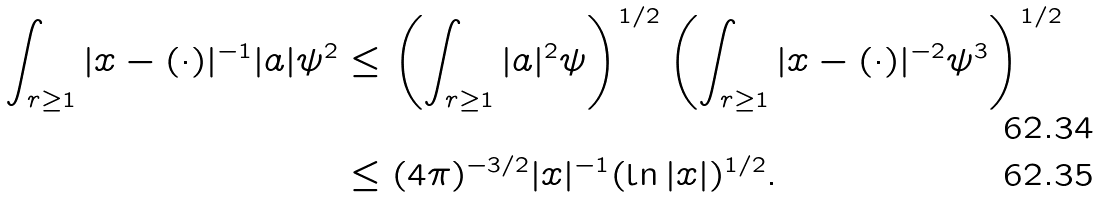<formula> <loc_0><loc_0><loc_500><loc_500>\int _ { r \geq 1 } | x - ( \cdot ) | ^ { - 1 } | a | \psi ^ { 2 } & \leq \left ( \int _ { r \geq 1 } | a | ^ { 2 } \psi \right ) ^ { 1 / 2 } \left ( \int _ { r \geq 1 } | x - ( \cdot ) | ^ { - 2 } \psi ^ { 3 } \right ) ^ { 1 / 2 } \\ & \leq ( 4 \pi ) ^ { - 3 / 2 } | x | ^ { - 1 } ( \ln | x | ) ^ { 1 / 2 } .</formula> 